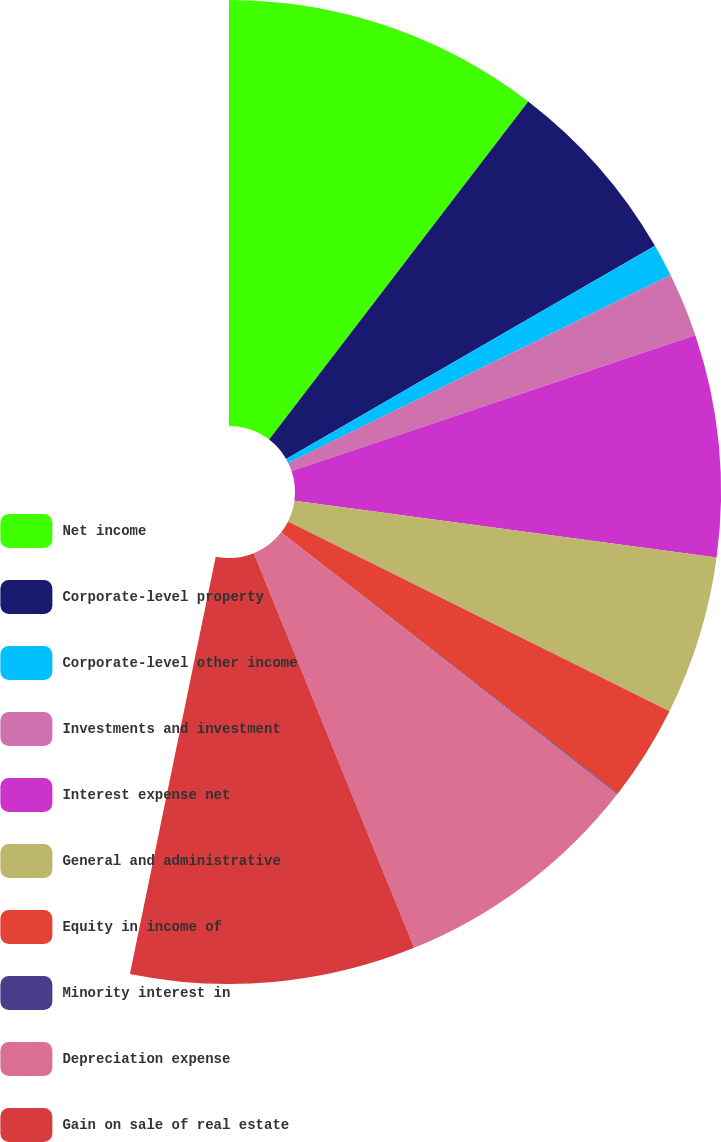<chart> <loc_0><loc_0><loc_500><loc_500><pie_chart><fcel>Net income<fcel>Corporate-level property<fcel>Corporate-level other income<fcel>Investments and investment<fcel>Interest expense net<fcel>General and administrative<fcel>Equity in income of<fcel>Minority interest in<fcel>Depreciation expense<fcel>Gain on sale of real estate<nl><fcel>19.55%<fcel>11.75%<fcel>2.01%<fcel>3.96%<fcel>13.7%<fcel>9.81%<fcel>5.91%<fcel>0.07%<fcel>15.65%<fcel>17.6%<nl></chart> 